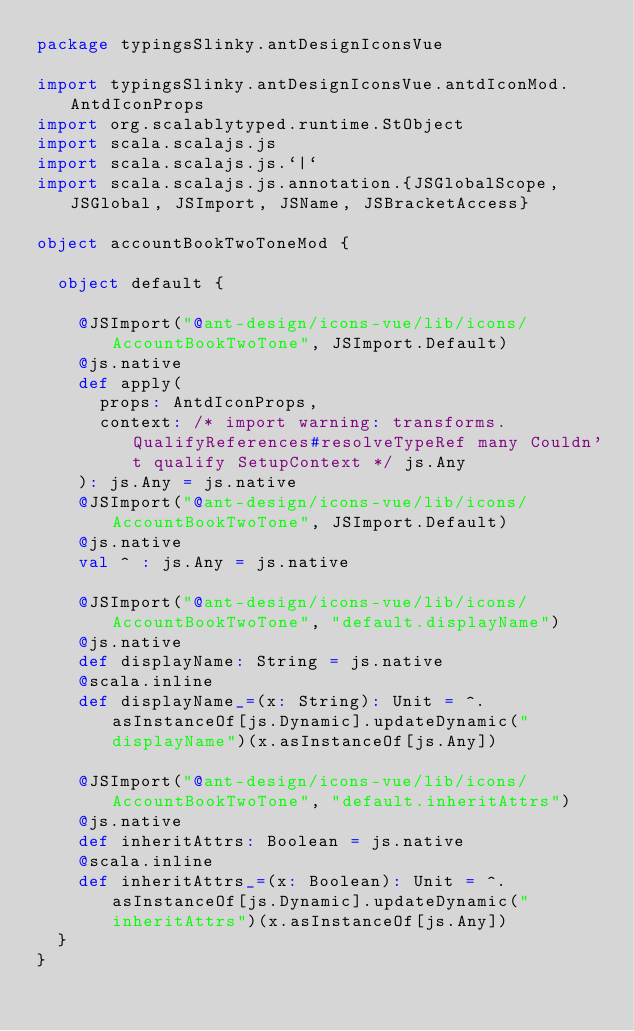<code> <loc_0><loc_0><loc_500><loc_500><_Scala_>package typingsSlinky.antDesignIconsVue

import typingsSlinky.antDesignIconsVue.antdIconMod.AntdIconProps
import org.scalablytyped.runtime.StObject
import scala.scalajs.js
import scala.scalajs.js.`|`
import scala.scalajs.js.annotation.{JSGlobalScope, JSGlobal, JSImport, JSName, JSBracketAccess}

object accountBookTwoToneMod {
  
  object default {
    
    @JSImport("@ant-design/icons-vue/lib/icons/AccountBookTwoTone", JSImport.Default)
    @js.native
    def apply(
      props: AntdIconProps,
      context: /* import warning: transforms.QualifyReferences#resolveTypeRef many Couldn't qualify SetupContext */ js.Any
    ): js.Any = js.native
    @JSImport("@ant-design/icons-vue/lib/icons/AccountBookTwoTone", JSImport.Default)
    @js.native
    val ^ : js.Any = js.native
    
    @JSImport("@ant-design/icons-vue/lib/icons/AccountBookTwoTone", "default.displayName")
    @js.native
    def displayName: String = js.native
    @scala.inline
    def displayName_=(x: String): Unit = ^.asInstanceOf[js.Dynamic].updateDynamic("displayName")(x.asInstanceOf[js.Any])
    
    @JSImport("@ant-design/icons-vue/lib/icons/AccountBookTwoTone", "default.inheritAttrs")
    @js.native
    def inheritAttrs: Boolean = js.native
    @scala.inline
    def inheritAttrs_=(x: Boolean): Unit = ^.asInstanceOf[js.Dynamic].updateDynamic("inheritAttrs")(x.asInstanceOf[js.Any])
  }
}
</code> 